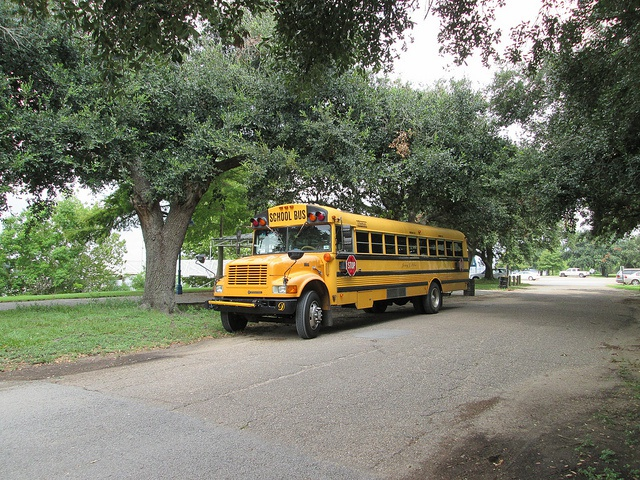Describe the objects in this image and their specific colors. I can see bus in gray, black, orange, and olive tones, truck in gray, white, darkgray, and lavender tones, car in gray, lightgray, darkgray, and beige tones, car in gray, darkgray, and black tones, and car in gray, white, and darkgray tones in this image. 